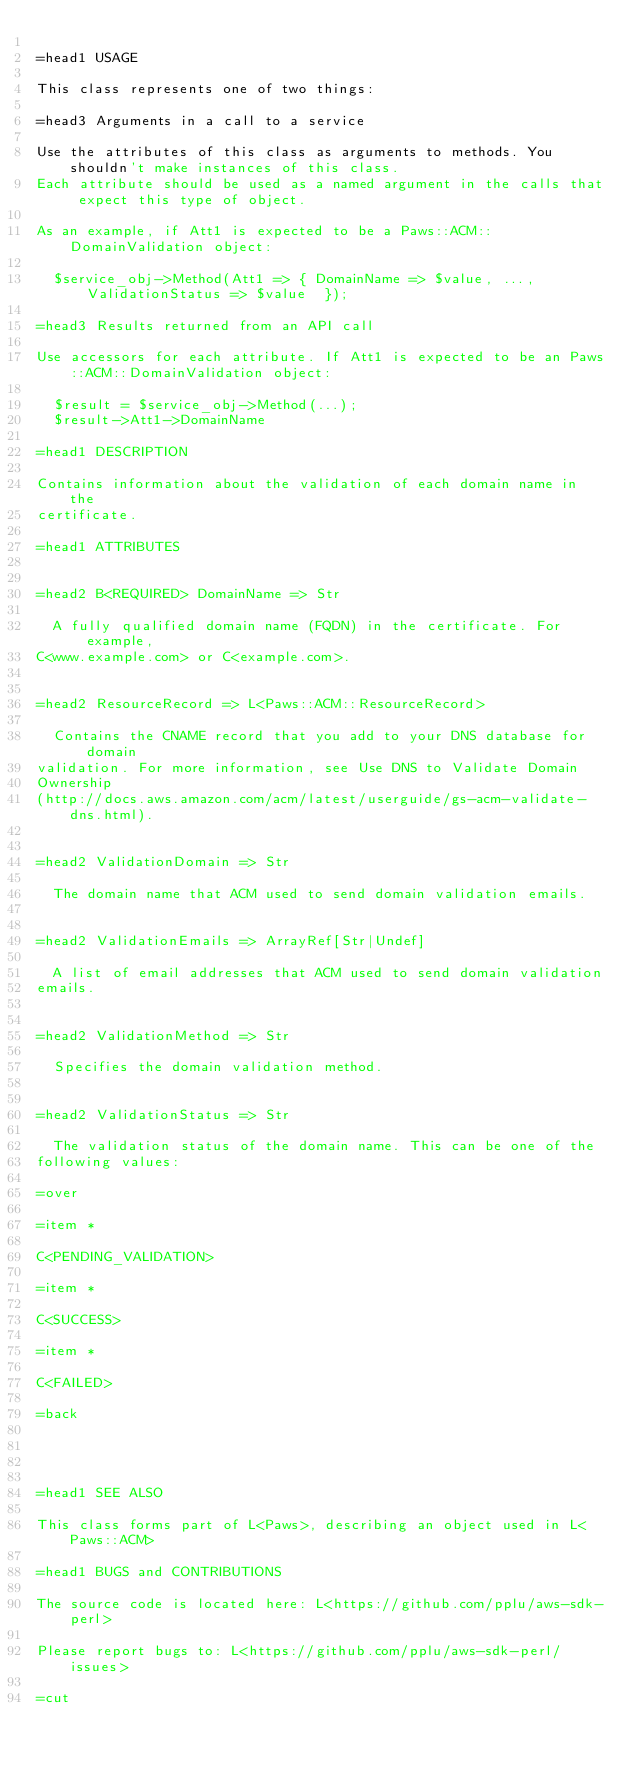<code> <loc_0><loc_0><loc_500><loc_500><_Perl_>
=head1 USAGE

This class represents one of two things:

=head3 Arguments in a call to a service

Use the attributes of this class as arguments to methods. You shouldn't make instances of this class. 
Each attribute should be used as a named argument in the calls that expect this type of object.

As an example, if Att1 is expected to be a Paws::ACM::DomainValidation object:

  $service_obj->Method(Att1 => { DomainName => $value, ..., ValidationStatus => $value  });

=head3 Results returned from an API call

Use accessors for each attribute. If Att1 is expected to be an Paws::ACM::DomainValidation object:

  $result = $service_obj->Method(...);
  $result->Att1->DomainName

=head1 DESCRIPTION

Contains information about the validation of each domain name in the
certificate.

=head1 ATTRIBUTES


=head2 B<REQUIRED> DomainName => Str

  A fully qualified domain name (FQDN) in the certificate. For example,
C<www.example.com> or C<example.com>.


=head2 ResourceRecord => L<Paws::ACM::ResourceRecord>

  Contains the CNAME record that you add to your DNS database for domain
validation. For more information, see Use DNS to Validate Domain
Ownership
(http://docs.aws.amazon.com/acm/latest/userguide/gs-acm-validate-dns.html).


=head2 ValidationDomain => Str

  The domain name that ACM used to send domain validation emails.


=head2 ValidationEmails => ArrayRef[Str|Undef]

  A list of email addresses that ACM used to send domain validation
emails.


=head2 ValidationMethod => Str

  Specifies the domain validation method.


=head2 ValidationStatus => Str

  The validation status of the domain name. This can be one of the
following values:

=over

=item *

C<PENDING_VALIDATION>

=item *

C<SUCCESS>

=item *

C<FAILED>

=back




=head1 SEE ALSO

This class forms part of L<Paws>, describing an object used in L<Paws::ACM>

=head1 BUGS and CONTRIBUTIONS

The source code is located here: L<https://github.com/pplu/aws-sdk-perl>

Please report bugs to: L<https://github.com/pplu/aws-sdk-perl/issues>

=cut

</code> 